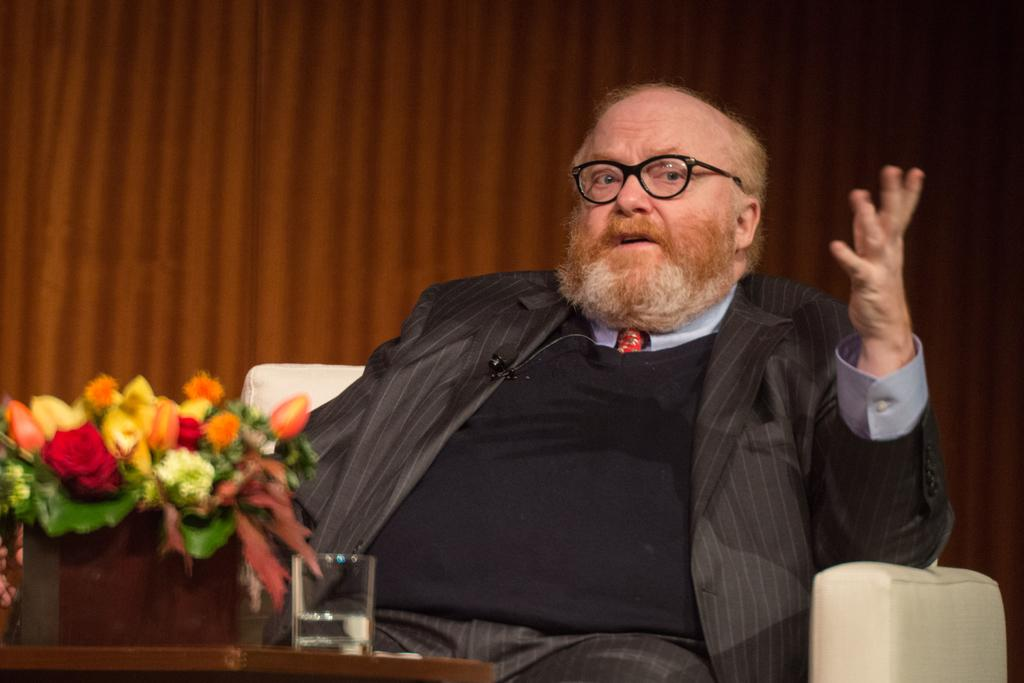What is the man in the image doing? The man is sitting on the couch in the image. What can be seen in the background of the image? There is a side table in the background of the image. What objects are on the side table? There is a glass tumbler and a flower vase on the side table. What is the title of the book the man is reading in the image? There is no book visible in the image, so it is not possible to determine the title. 